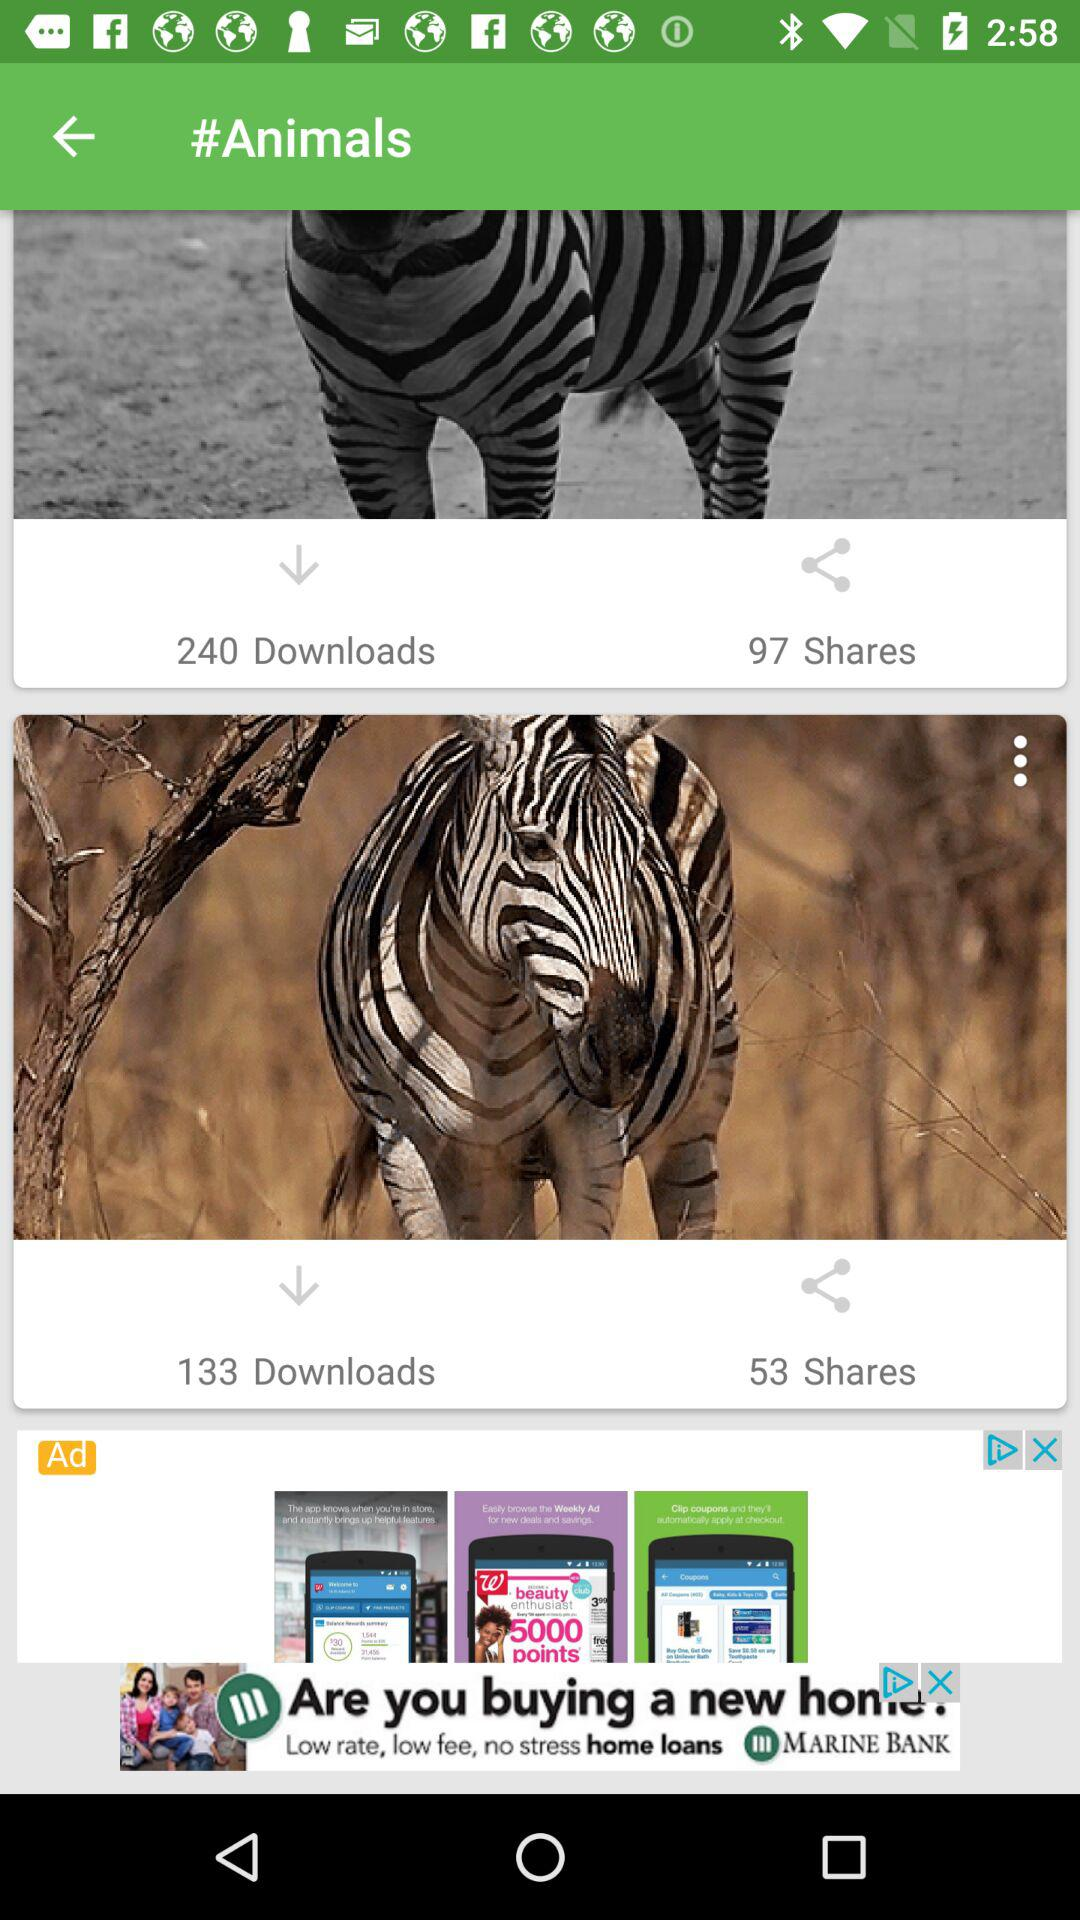What is the number of downloads? The numbers of downloads are 240 and 133. 